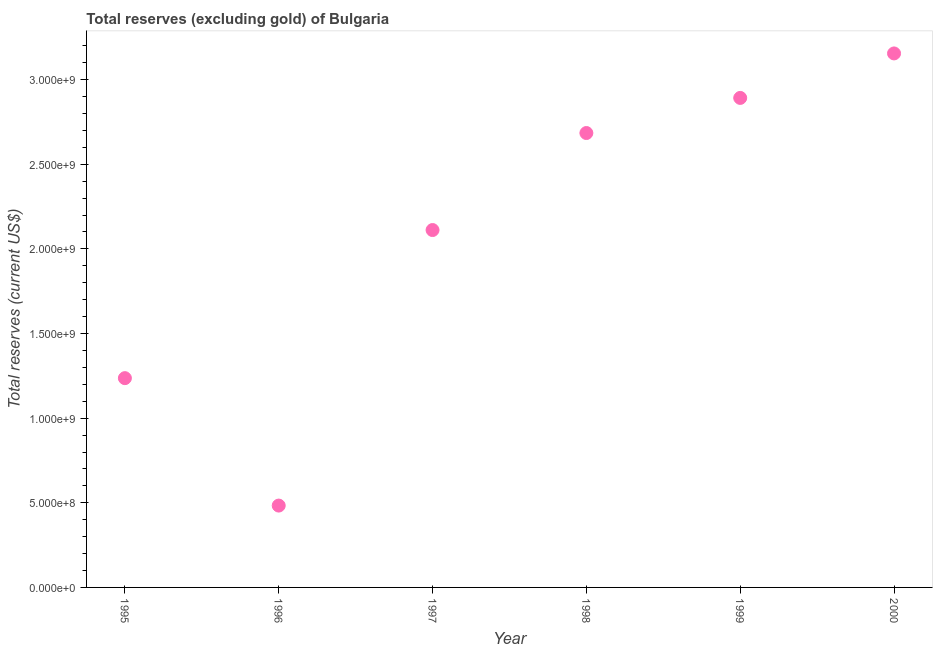What is the total reserves (excluding gold) in 1999?
Ensure brevity in your answer.  2.89e+09. Across all years, what is the maximum total reserves (excluding gold)?
Your response must be concise. 3.15e+09. Across all years, what is the minimum total reserves (excluding gold)?
Make the answer very short. 4.84e+08. In which year was the total reserves (excluding gold) maximum?
Give a very brief answer. 2000. In which year was the total reserves (excluding gold) minimum?
Give a very brief answer. 1996. What is the sum of the total reserves (excluding gold)?
Your answer should be very brief. 1.26e+1. What is the difference between the total reserves (excluding gold) in 1997 and 1999?
Ensure brevity in your answer.  -7.81e+08. What is the average total reserves (excluding gold) per year?
Make the answer very short. 2.09e+09. What is the median total reserves (excluding gold)?
Offer a very short reply. 2.40e+09. What is the ratio of the total reserves (excluding gold) in 1996 to that in 1998?
Your answer should be very brief. 0.18. What is the difference between the highest and the second highest total reserves (excluding gold)?
Give a very brief answer. 2.63e+08. Is the sum of the total reserves (excluding gold) in 1996 and 1999 greater than the maximum total reserves (excluding gold) across all years?
Provide a succinct answer. Yes. What is the difference between the highest and the lowest total reserves (excluding gold)?
Keep it short and to the point. 2.67e+09. In how many years, is the total reserves (excluding gold) greater than the average total reserves (excluding gold) taken over all years?
Make the answer very short. 4. Does the total reserves (excluding gold) monotonically increase over the years?
Keep it short and to the point. No. How many dotlines are there?
Ensure brevity in your answer.  1. How many years are there in the graph?
Your answer should be very brief. 6. Does the graph contain any zero values?
Offer a terse response. No. Does the graph contain grids?
Provide a short and direct response. No. What is the title of the graph?
Your answer should be very brief. Total reserves (excluding gold) of Bulgaria. What is the label or title of the Y-axis?
Give a very brief answer. Total reserves (current US$). What is the Total reserves (current US$) in 1995?
Your answer should be compact. 1.24e+09. What is the Total reserves (current US$) in 1996?
Your answer should be compact. 4.84e+08. What is the Total reserves (current US$) in 1997?
Keep it short and to the point. 2.11e+09. What is the Total reserves (current US$) in 1998?
Your answer should be very brief. 2.68e+09. What is the Total reserves (current US$) in 1999?
Provide a succinct answer. 2.89e+09. What is the Total reserves (current US$) in 2000?
Your answer should be compact. 3.15e+09. What is the difference between the Total reserves (current US$) in 1995 and 1996?
Give a very brief answer. 7.53e+08. What is the difference between the Total reserves (current US$) in 1995 and 1997?
Keep it short and to the point. -8.75e+08. What is the difference between the Total reserves (current US$) in 1995 and 1998?
Provide a succinct answer. -1.45e+09. What is the difference between the Total reserves (current US$) in 1995 and 1999?
Ensure brevity in your answer.  -1.66e+09. What is the difference between the Total reserves (current US$) in 1995 and 2000?
Give a very brief answer. -1.92e+09. What is the difference between the Total reserves (current US$) in 1996 and 1997?
Your answer should be very brief. -1.63e+09. What is the difference between the Total reserves (current US$) in 1996 and 1998?
Give a very brief answer. -2.20e+09. What is the difference between the Total reserves (current US$) in 1996 and 1999?
Your answer should be compact. -2.41e+09. What is the difference between the Total reserves (current US$) in 1996 and 2000?
Ensure brevity in your answer.  -2.67e+09. What is the difference between the Total reserves (current US$) in 1997 and 1998?
Your answer should be compact. -5.73e+08. What is the difference between the Total reserves (current US$) in 1997 and 1999?
Your response must be concise. -7.81e+08. What is the difference between the Total reserves (current US$) in 1997 and 2000?
Your answer should be very brief. -1.04e+09. What is the difference between the Total reserves (current US$) in 1998 and 1999?
Provide a succinct answer. -2.07e+08. What is the difference between the Total reserves (current US$) in 1998 and 2000?
Offer a terse response. -4.70e+08. What is the difference between the Total reserves (current US$) in 1999 and 2000?
Make the answer very short. -2.63e+08. What is the ratio of the Total reserves (current US$) in 1995 to that in 1996?
Provide a short and direct response. 2.56. What is the ratio of the Total reserves (current US$) in 1995 to that in 1997?
Ensure brevity in your answer.  0.59. What is the ratio of the Total reserves (current US$) in 1995 to that in 1998?
Your answer should be compact. 0.46. What is the ratio of the Total reserves (current US$) in 1995 to that in 1999?
Provide a succinct answer. 0.43. What is the ratio of the Total reserves (current US$) in 1995 to that in 2000?
Keep it short and to the point. 0.39. What is the ratio of the Total reserves (current US$) in 1996 to that in 1997?
Offer a terse response. 0.23. What is the ratio of the Total reserves (current US$) in 1996 to that in 1998?
Provide a succinct answer. 0.18. What is the ratio of the Total reserves (current US$) in 1996 to that in 1999?
Offer a very short reply. 0.17. What is the ratio of the Total reserves (current US$) in 1996 to that in 2000?
Keep it short and to the point. 0.15. What is the ratio of the Total reserves (current US$) in 1997 to that in 1998?
Your response must be concise. 0.79. What is the ratio of the Total reserves (current US$) in 1997 to that in 1999?
Make the answer very short. 0.73. What is the ratio of the Total reserves (current US$) in 1997 to that in 2000?
Offer a terse response. 0.67. What is the ratio of the Total reserves (current US$) in 1998 to that in 1999?
Your response must be concise. 0.93. What is the ratio of the Total reserves (current US$) in 1998 to that in 2000?
Ensure brevity in your answer.  0.85. What is the ratio of the Total reserves (current US$) in 1999 to that in 2000?
Ensure brevity in your answer.  0.92. 